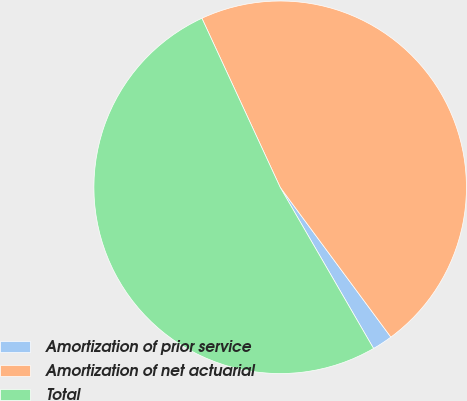Convert chart. <chart><loc_0><loc_0><loc_500><loc_500><pie_chart><fcel>Amortization of prior service<fcel>Amortization of net actuarial<fcel>Total<nl><fcel>1.77%<fcel>46.78%<fcel>51.46%<nl></chart> 